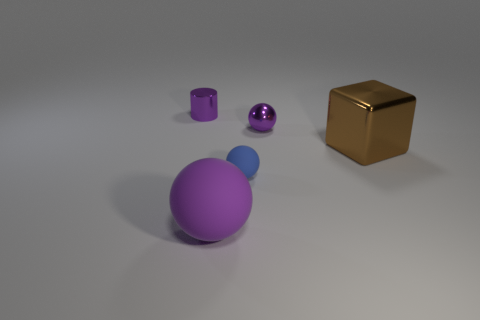Subtract 1 balls. How many balls are left? 2 Add 1 tiny blue things. How many objects exist? 6 Subtract all blocks. How many objects are left? 4 Subtract all large purple matte balls. Subtract all green balls. How many objects are left? 4 Add 4 small purple shiny things. How many small purple shiny things are left? 6 Add 1 big brown balls. How many big brown balls exist? 1 Subtract 0 blue blocks. How many objects are left? 5 